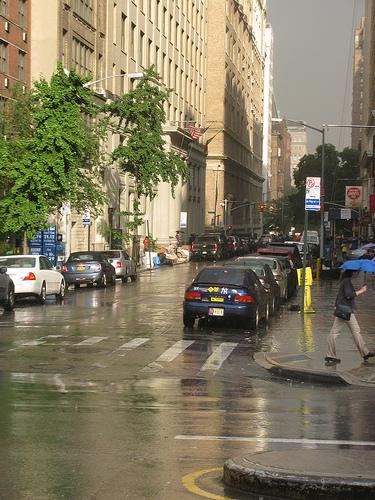Briefly express the key elements and action in the picture. City street scene with parked cars, a walking woman with a blue umbrella and various street signs and objects. Mention what the central focus of the image is and what is happening in the scene. The image shows a city street with cars parked on both sides and a woman holding a blue umbrella walking on the sidewalk. Reveal the most prominent parts of the image and the ongoing activity in a short sentence. A woman walks with a blue umbrella near a line of parked cars on the street. Write a phrase that captures the essence of the image and the principal activity. Woman strolling with blue umbrella along parked cars on a city street. Using simple language, explain what the image primarily depicts and the action taking place. A lady is walking with a blue umbrella on a street with many parked cars. In a few words, highlight the main subject and their action in the image. Woman with blue umbrella walking by parked cars. State the primary object and its activity in the image briefly. Woman holding a blue umbrella walking on a city street with parked cars. Summarize the most important aspects of the image in one sentence. A woman with a blue umbrella walks alongside a row of parked cars on a city street. Create a short description of the main components of the picture and what is happening. City street, parked cars, woman with a blue umbrella walking on sidewalk. In a concise manner, describe the main subject and their activity in the image. Woman walking under blue umbrella beside parked cars on a city street. 